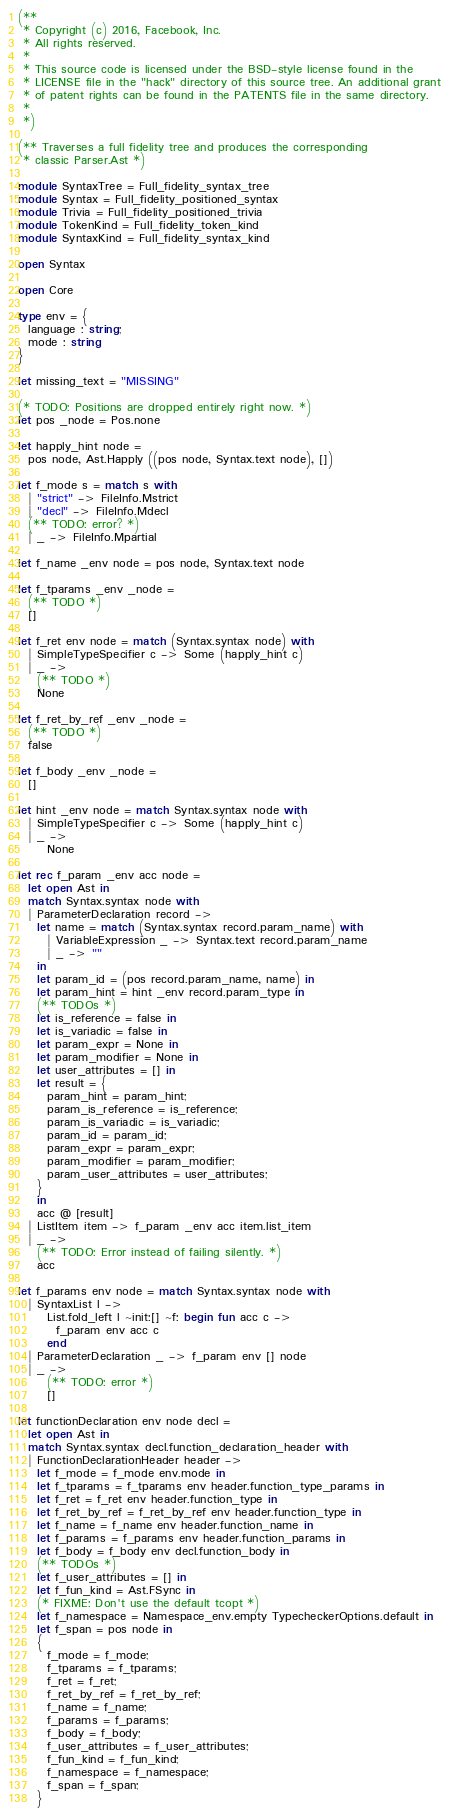Convert code to text. <code><loc_0><loc_0><loc_500><loc_500><_OCaml_>(**
 * Copyright (c) 2016, Facebook, Inc.
 * All rights reserved.
 *
 * This source code is licensed under the BSD-style license found in the
 * LICENSE file in the "hack" directory of this source tree. An additional grant
 * of patent rights can be found in the PATENTS file in the same directory.
 *
 *)

(** Traverses a full fidelity tree and produces the corresponding
 * classic Parser.Ast *)

module SyntaxTree = Full_fidelity_syntax_tree
module Syntax = Full_fidelity_positioned_syntax
module Trivia = Full_fidelity_positioned_trivia
module TokenKind = Full_fidelity_token_kind
module SyntaxKind = Full_fidelity_syntax_kind

open Syntax

open Core

type env = {
  language : string;
  mode : string
}

let missing_text = "MISSING"

(* TODO: Positions are dropped entirely right now. *)
let pos _node = Pos.none

let happly_hint node =
  pos node, Ast.Happly ((pos node, Syntax.text node), [])

let f_mode s = match s with
  | "strict" -> FileInfo.Mstrict
  | "decl" -> FileInfo.Mdecl
  (** TODO: error? *)
  | _ -> FileInfo.Mpartial

let f_name _env node = pos node, Syntax.text node

let f_tparams _env _node =
  (** TODO *)
  []

let f_ret env node = match (Syntax.syntax node) with
  | SimpleTypeSpecifier c -> Some (happly_hint c)
  | _ ->
    (** TODO *)
    None

let f_ret_by_ref _env _node =
  (** TODO *)
  false

let f_body _env _node =
  []

let hint _env node = match Syntax.syntax node with
  | SimpleTypeSpecifier c -> Some (happly_hint c)
  | _ ->
      None

let rec f_param _env acc node =
  let open Ast in
  match Syntax.syntax node with
  | ParameterDeclaration record ->
    let name = match (Syntax.syntax record.param_name) with
      | VariableExpression _ -> Syntax.text record.param_name
      | _ -> ""
    in
    let param_id = (pos record.param_name, name) in
    let param_hint = hint _env record.param_type in
    (** TODOs *)
    let is_reference = false in
    let is_variadic = false in
    let param_expr = None in
    let param_modifier = None in
    let user_attributes = [] in
    let result = {
      param_hint = param_hint;
      param_is_reference = is_reference;
      param_is_variadic = is_variadic;
      param_id = param_id;
      param_expr = param_expr;
      param_modifier = param_modifier;
      param_user_attributes = user_attributes;
    }
    in
    acc @ [result]
  | ListItem item -> f_param _env acc item.list_item
  | _ ->
    (** TODO: Error instead of failing silently. *)
    acc

let f_params env node = match Syntax.syntax node with
  | SyntaxList l ->
      List.fold_left l ~init:[] ~f: begin fun acc c ->
        f_param env acc c
      end
  | ParameterDeclaration _ -> f_param env [] node
  | _ ->
      (** TODO: error *)
      []

let functionDeclaration env node decl =
  let open Ast in
  match Syntax.syntax decl.function_declaration_header with
  | FunctionDeclarationHeader header ->
    let f_mode = f_mode env.mode in
    let f_tparams = f_tparams env header.function_type_params in
    let f_ret = f_ret env header.function_type in
    let f_ret_by_ref = f_ret_by_ref env header.function_type in
    let f_name = f_name env header.function_name in
    let f_params = f_params env header.function_params in
    let f_body = f_body env decl.function_body in
    (** TODOs *)
    let f_user_attributes = [] in
    let f_fun_kind = Ast.FSync in
    (* FIXME: Don't use the default tcopt *)
    let f_namespace = Namespace_env.empty TypecheckerOptions.default in
    let f_span = pos node in
    {
      f_mode = f_mode;
      f_tparams = f_tparams;
      f_ret = f_ret;
      f_ret_by_ref = f_ret_by_ref;
      f_name = f_name;
      f_params = f_params;
      f_body = f_body;
      f_user_attributes = f_user_attributes;
      f_fun_kind = f_fun_kind;
      f_namespace = f_namespace;
      f_span = f_span;
    }</code> 